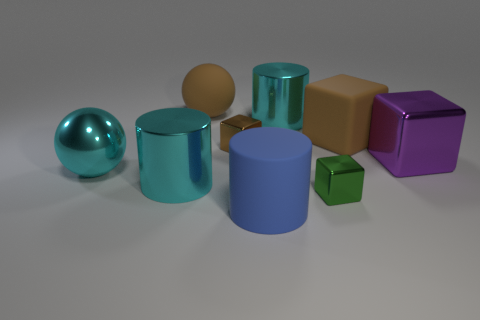How many cyan cylinders must be subtracted to get 1 cyan cylinders? 1 Add 1 big purple things. How many objects exist? 10 Subtract all cubes. How many objects are left? 5 Subtract all tiny brown matte balls. Subtract all large cubes. How many objects are left? 7 Add 2 large matte blocks. How many large matte blocks are left? 3 Add 7 green shiny things. How many green shiny things exist? 8 Subtract 0 yellow cylinders. How many objects are left? 9 